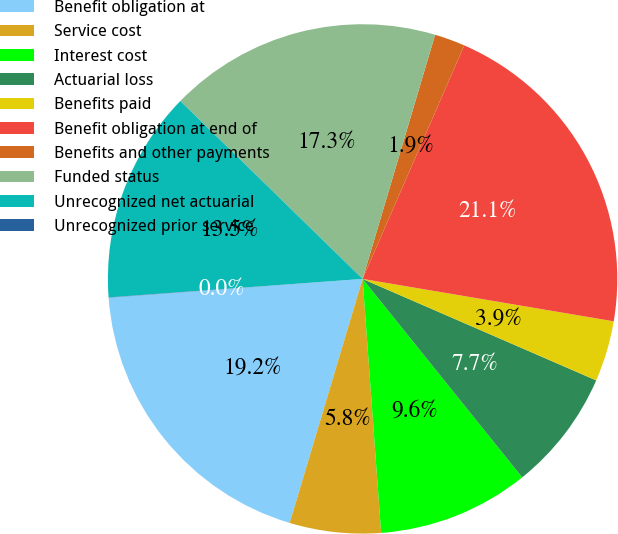<chart> <loc_0><loc_0><loc_500><loc_500><pie_chart><fcel>Benefit obligation at<fcel>Service cost<fcel>Interest cost<fcel>Actuarial loss<fcel>Benefits paid<fcel>Benefit obligation at end of<fcel>Benefits and other payments<fcel>Funded status<fcel>Unrecognized net actuarial<fcel>Unrecognized prior service<nl><fcel>19.21%<fcel>5.78%<fcel>9.62%<fcel>7.7%<fcel>3.86%<fcel>21.13%<fcel>1.94%<fcel>17.29%<fcel>13.46%<fcel>0.02%<nl></chart> 